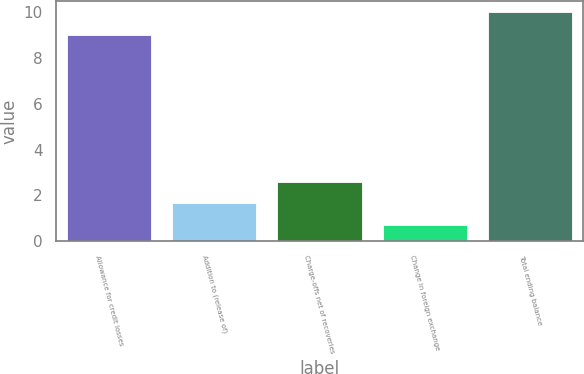<chart> <loc_0><loc_0><loc_500><loc_500><bar_chart><fcel>Allowance for credit losses<fcel>Addition to (release of)<fcel>Charge-offs net of recoveries<fcel>Change in foreign exchange<fcel>Total ending balance<nl><fcel>9<fcel>1.66<fcel>2.59<fcel>0.73<fcel>10<nl></chart> 